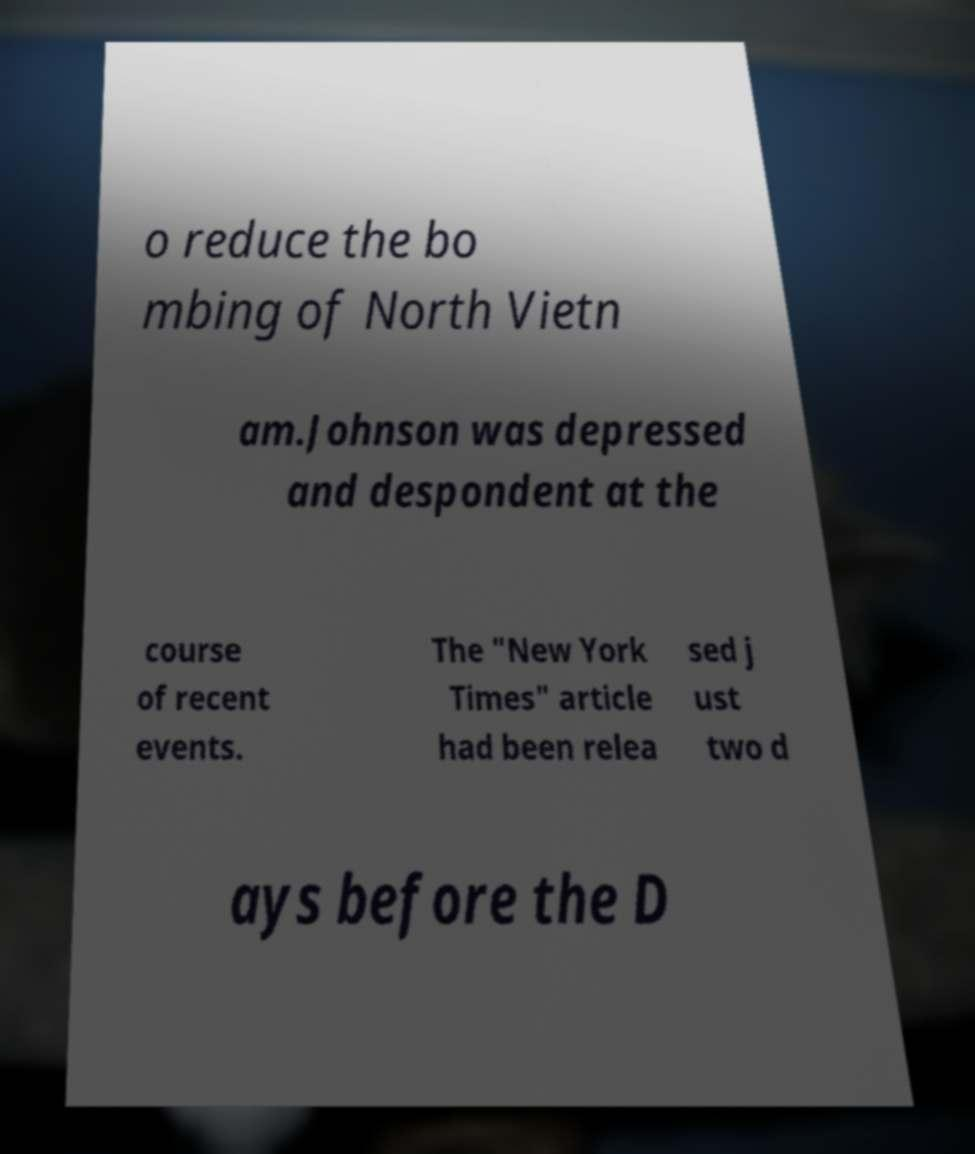Could you extract and type out the text from this image? o reduce the bo mbing of North Vietn am.Johnson was depressed and despondent at the course of recent events. The "New York Times" article had been relea sed j ust two d ays before the D 